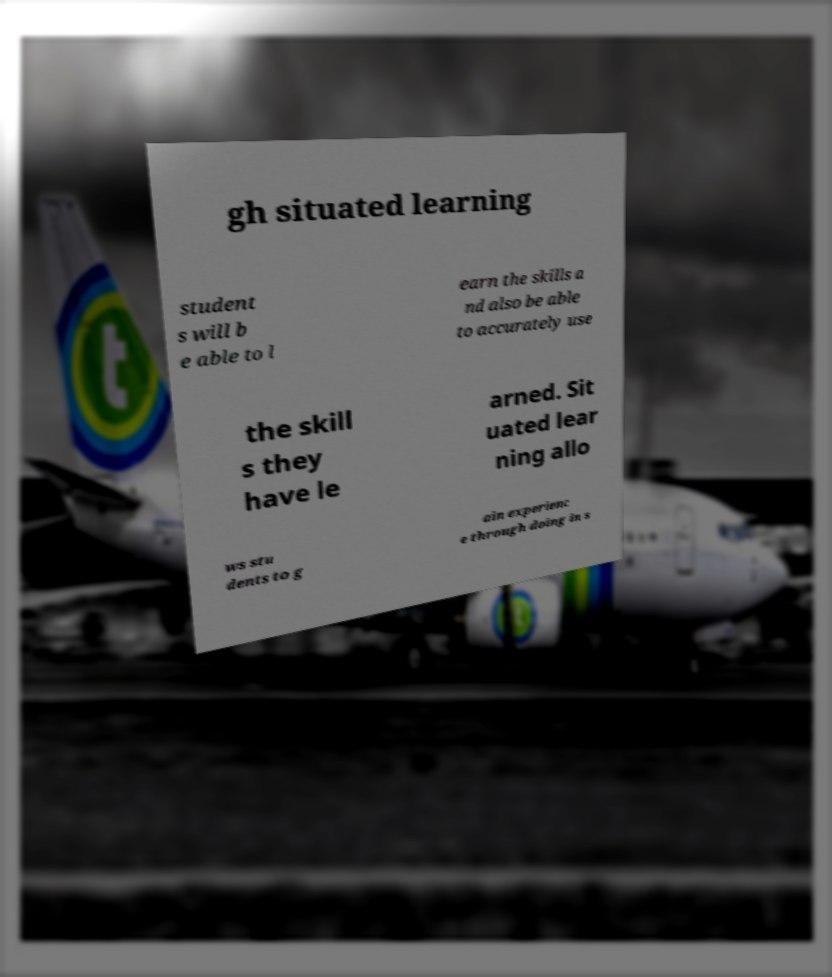Could you assist in decoding the text presented in this image and type it out clearly? gh situated learning student s will b e able to l earn the skills a nd also be able to accurately use the skill s they have le arned. Sit uated lear ning allo ws stu dents to g ain experienc e through doing in s 